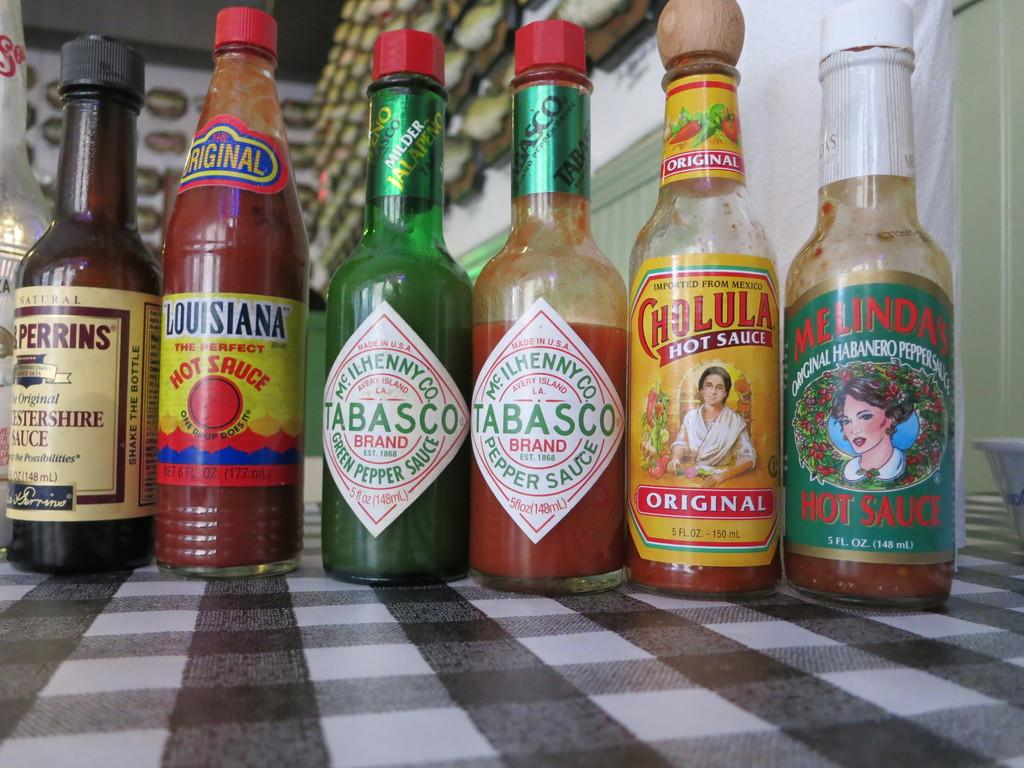<image>
Present a compact description of the photo's key features. Two bottles of Tabasco are next to a bottle of Louisiana hot sauce. 